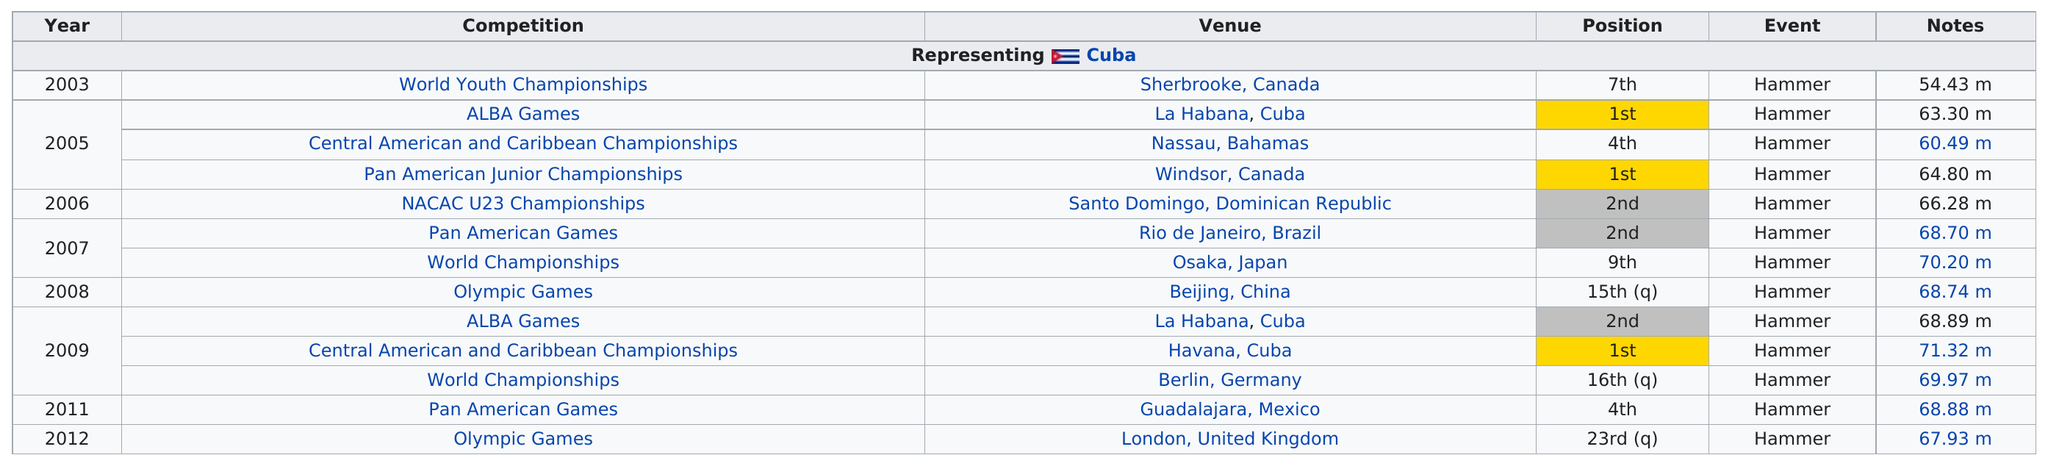Outline some significant characteristics in this image. Arasay Thondike did not finish in the top 20 in the 2012 Olympic Games. Three competitions were held in Cuba. At the 2008 Olympic Games, the participant held the 15th position. The number one position was earned three times. The second-placed candidate was placed in the second position a total of three times. 